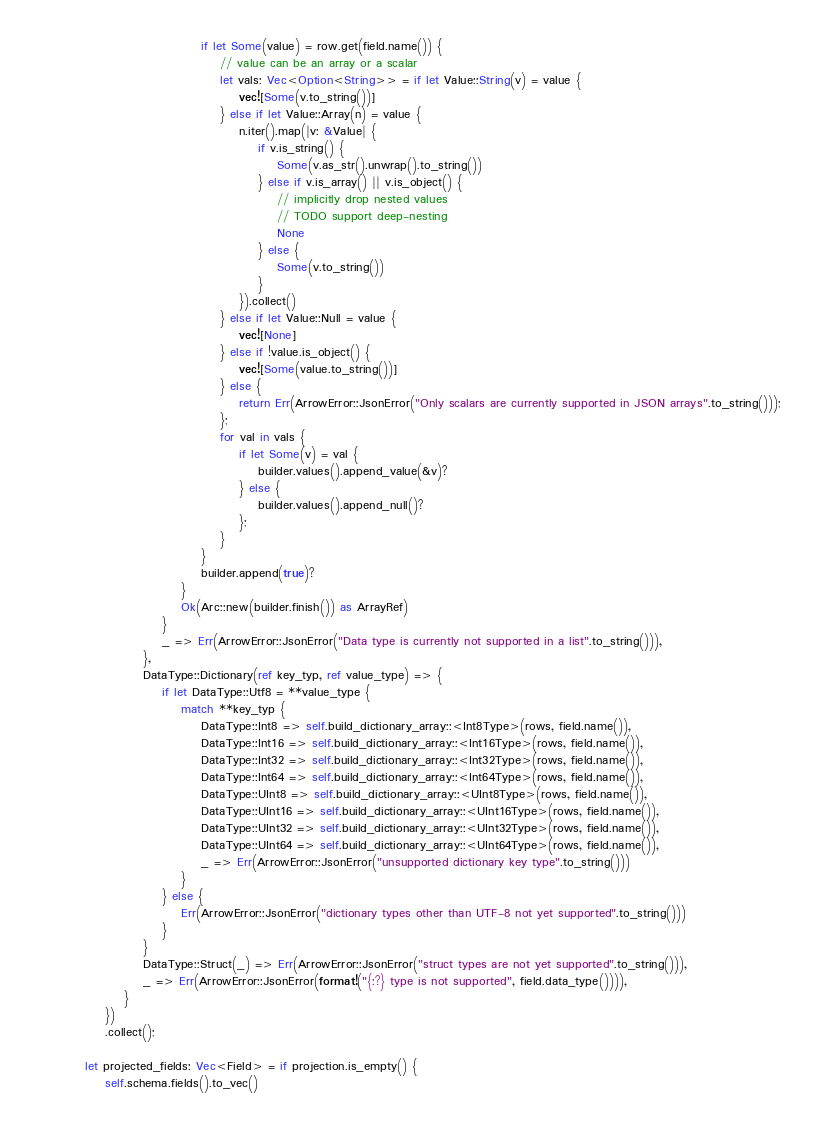<code> <loc_0><loc_0><loc_500><loc_500><_Rust_>                                if let Some(value) = row.get(field.name()) {
                                    // value can be an array or a scalar
                                    let vals: Vec<Option<String>> = if let Value::String(v) = value {
                                        vec![Some(v.to_string())]
                                    } else if let Value::Array(n) = value {
                                        n.iter().map(|v: &Value| {
                                            if v.is_string() {
                                                Some(v.as_str().unwrap().to_string())
                                            } else if v.is_array() || v.is_object() {
                                                // implicitly drop nested values
                                                // TODO support deep-nesting
                                                None
                                            } else {
                                                Some(v.to_string())
                                            }
                                        }).collect()
                                    } else if let Value::Null = value {
                                        vec![None]
                                    } else if !value.is_object() {
                                        vec![Some(value.to_string())]
                                    } else {
                                        return Err(ArrowError::JsonError("Only scalars are currently supported in JSON arrays".to_string()));
                                    };
                                    for val in vals {
                                        if let Some(v) = val {
                                            builder.values().append_value(&v)?
                                        } else {
                                            builder.values().append_null()?
                                        };
                                    }
                                }
                                builder.append(true)?
                            }
                            Ok(Arc::new(builder.finish()) as ArrayRef)
                        }
                        _ => Err(ArrowError::JsonError("Data type is currently not supported in a list".to_string())),
                    },
                    DataType::Dictionary(ref key_typ, ref value_type) => {
                        if let DataType::Utf8 = **value_type {
                            match **key_typ {
                                DataType::Int8 => self.build_dictionary_array::<Int8Type>(rows, field.name()),
                                DataType::Int16 => self.build_dictionary_array::<Int16Type>(rows, field.name()),
                                DataType::Int32 => self.build_dictionary_array::<Int32Type>(rows, field.name()),
                                DataType::Int64 => self.build_dictionary_array::<Int64Type>(rows, field.name()),
                                DataType::UInt8 => self.build_dictionary_array::<UInt8Type>(rows, field.name()),
                                DataType::UInt16 => self.build_dictionary_array::<UInt16Type>(rows, field.name()),
                                DataType::UInt32 => self.build_dictionary_array::<UInt32Type>(rows, field.name()),
                                DataType::UInt64 => self.build_dictionary_array::<UInt64Type>(rows, field.name()),
                                _ => Err(ArrowError::JsonError("unsupported dictionary key type".to_string()))
                            }
                        } else {
                            Err(ArrowError::JsonError("dictionary types other than UTF-8 not yet supported".to_string()))
                        }
                    }
                    DataType::Struct(_) => Err(ArrowError::JsonError("struct types are not yet supported".to_string())),
                    _ => Err(ArrowError::JsonError(format!("{:?} type is not supported", field.data_type()))),
                }
            })
            .collect();

        let projected_fields: Vec<Field> = if projection.is_empty() {
            self.schema.fields().to_vec()</code> 